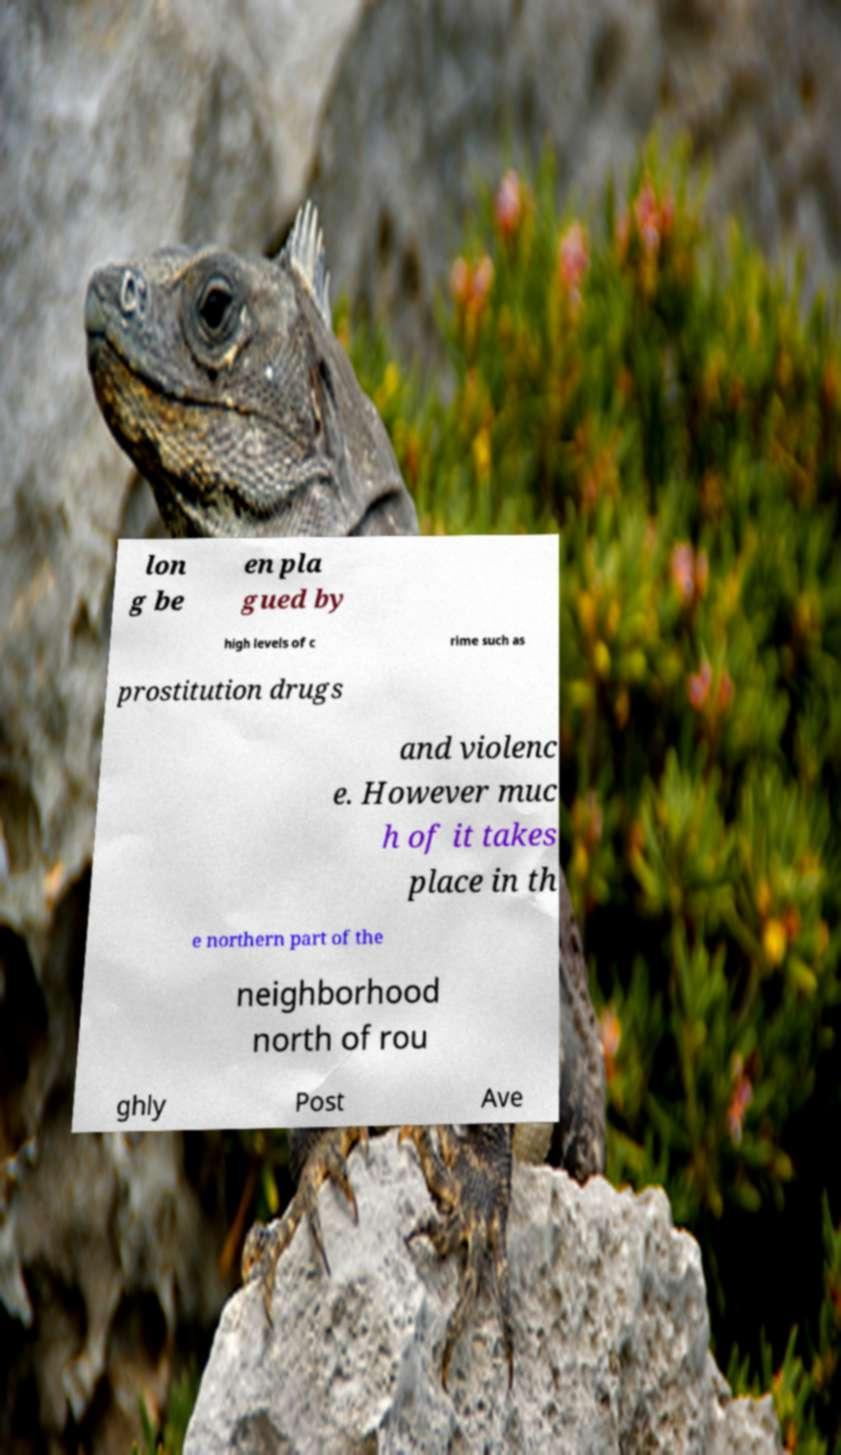For documentation purposes, I need the text within this image transcribed. Could you provide that? lon g be en pla gued by high levels of c rime such as prostitution drugs and violenc e. However muc h of it takes place in th e northern part of the neighborhood north of rou ghly Post Ave 